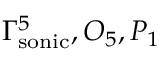Convert formula to latex. <formula><loc_0><loc_0><loc_500><loc_500>\Gamma _ { s o n i c } ^ { 5 } , O _ { 5 } , P _ { 1 }</formula> 